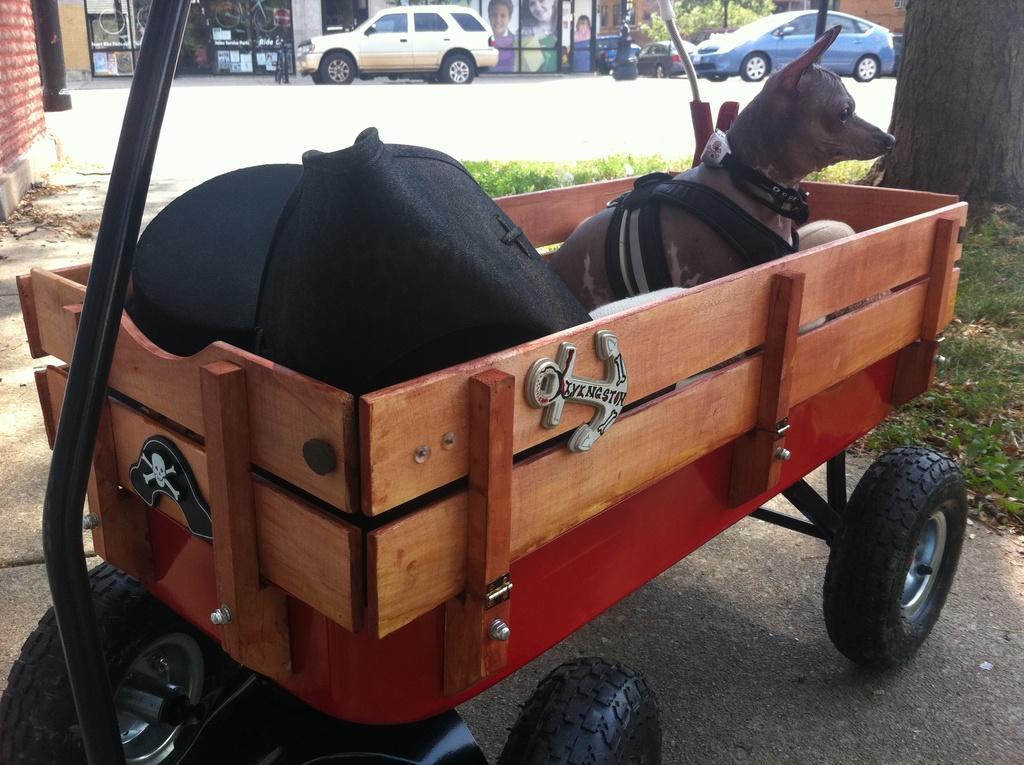Could you give a brief overview of what you see in this image? In the image we can see there is a dog sitting in the basket cart and the basket cart is parked on the road. There are clothes kept in the cart and there is a tree. The ground is covered with grass, behind there are cars parked on the road and there are buildings. 